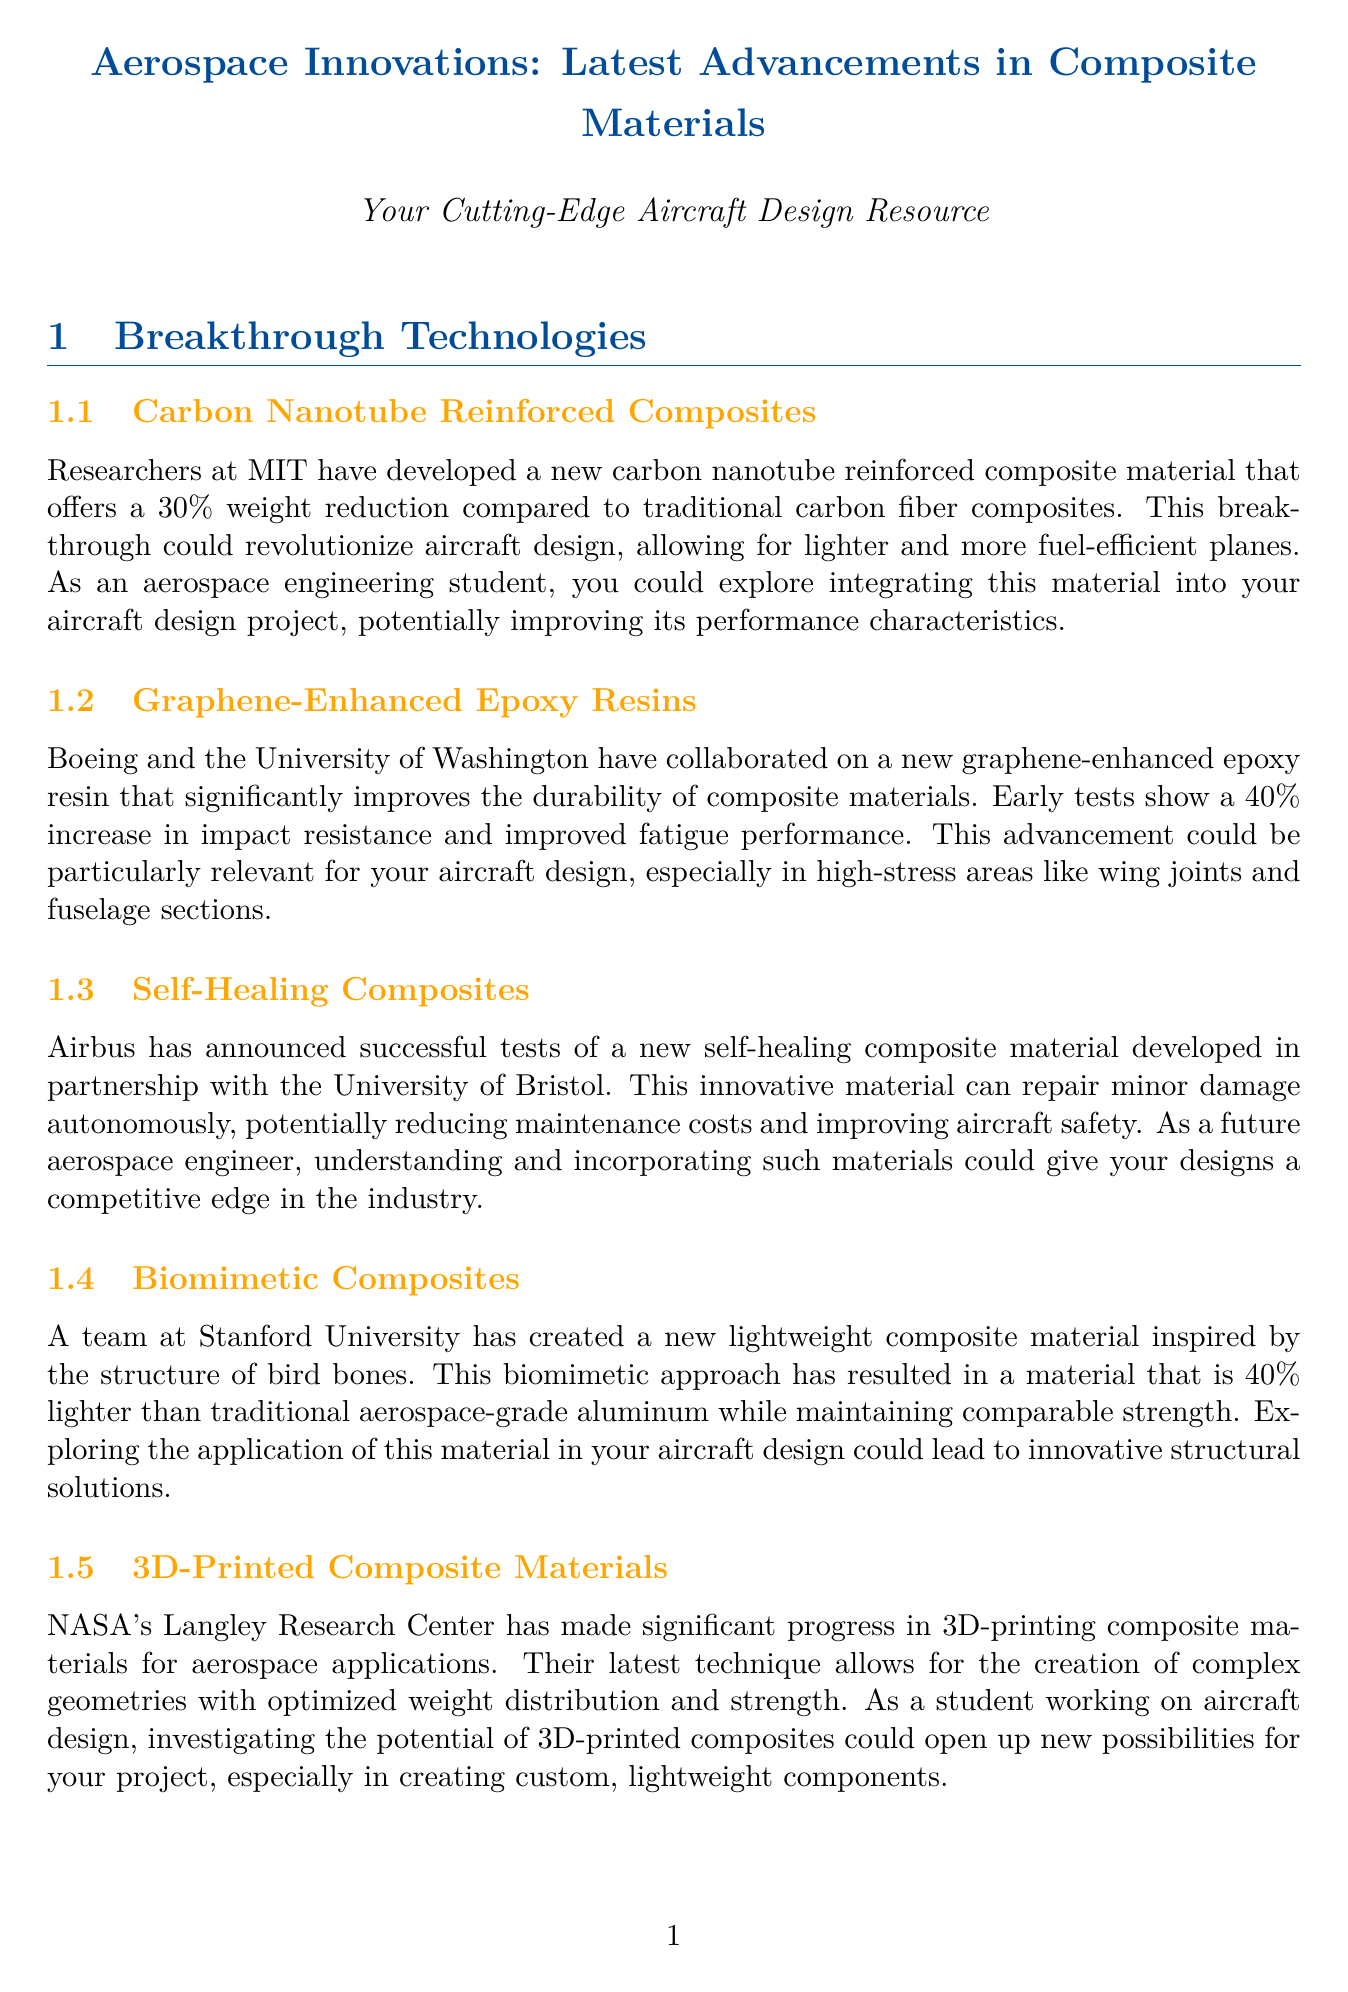What is the percentage of weight reduction offered by the new carbon nanotube reinforced composite? The document states that the new carbon nanotube reinforced composite offers a 30% weight reduction compared to traditional carbon fiber composites.
Answer: 30% Which institution collaborated with Boeing on graphene-enhanced epoxy resins? The document mentions that Boeing collaborated with the University of Washington on the new graphene-enhanced epoxy resin.
Answer: University of Washington What is the percentage increase in impact resistance for the graphene-enhanced epoxy resins? According to the content, early tests show a 40% increase in impact resistance for the graphene-enhanced epoxy resins.
Answer: 40% What military aircraft is potentially impacted by self-healing composites? The document describes that Airbus' new self-healing composite material can improve aircraft safety and reduce maintenance costs, which could potentially impact various aircraft types.
Answer: Various aircraft types How much lighter is the new biomimetic composite compared to traditional aluminum? The document states that the new biomimetic composite is 40% lighter than traditional aerospace-grade aluminum.
Answer: 40% Which organization can you join to stay updated on the latest research in composite structures? The document suggests joining the American Institute of Aeronautics and Astronautics (AIAA) Composite Structures Technical Committee for updates on research.
Answer: AIAA Composite Structures Technical Committee What type of advancements does NASA's Langley Research Center make in 3D-printed composite materials? The document discusses NASA's advancements in creating complex geometries with optimized weight distribution and strength through 3D-printing.
Answer: Complex geometries What is the main benefit of the self-healing composites? The document highlights that the main benefit of self-healing composites is their ability to autonomously repair minor damage, reducing maintenance costs.
Answer: Autonomous repair What educational resource is available for advancements in aerospace composites? The newsletter mentions an online course offered by TU Delft on edX about the latest advancements in aerospace composites as an educational resource.
Answer: TU Delft on edX 